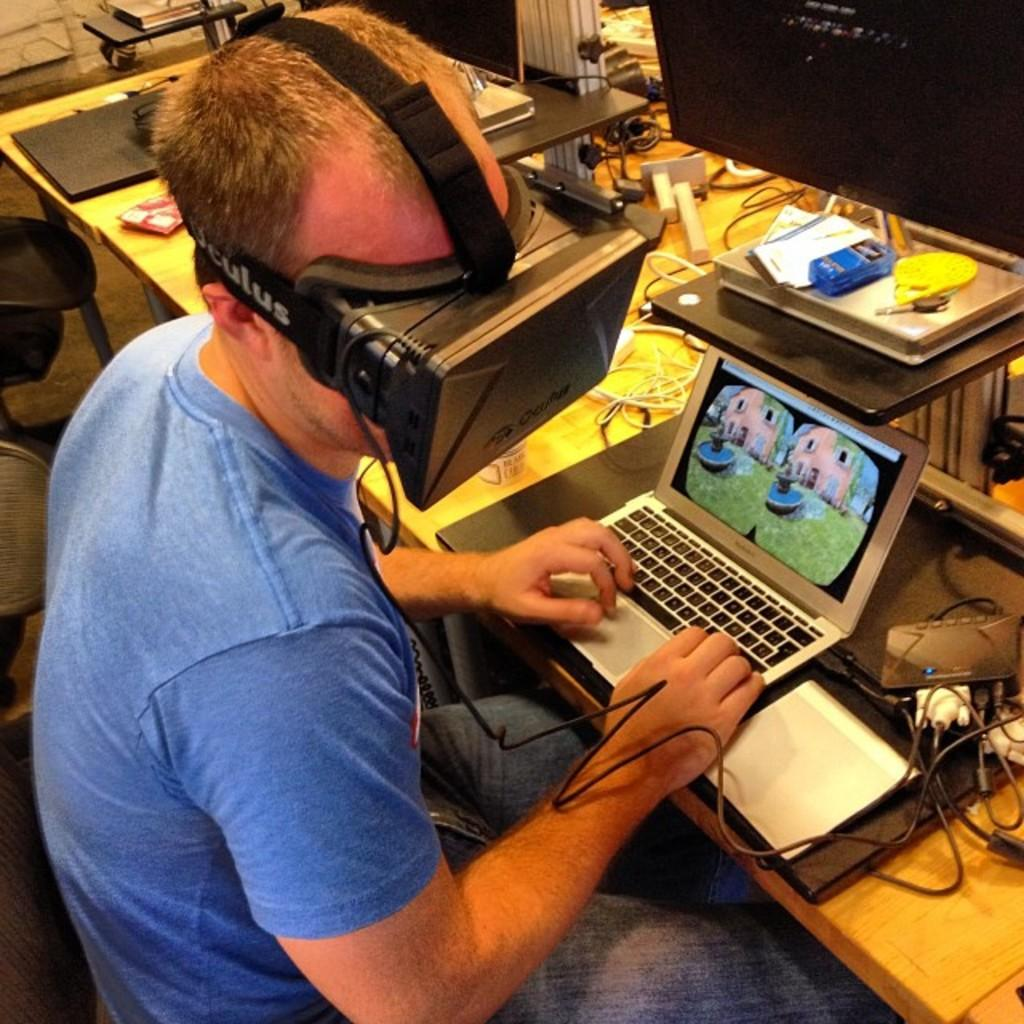<image>
Give a short and clear explanation of the subsequent image. Man on laptop wearing an Oculus virtual reality veiwer. 